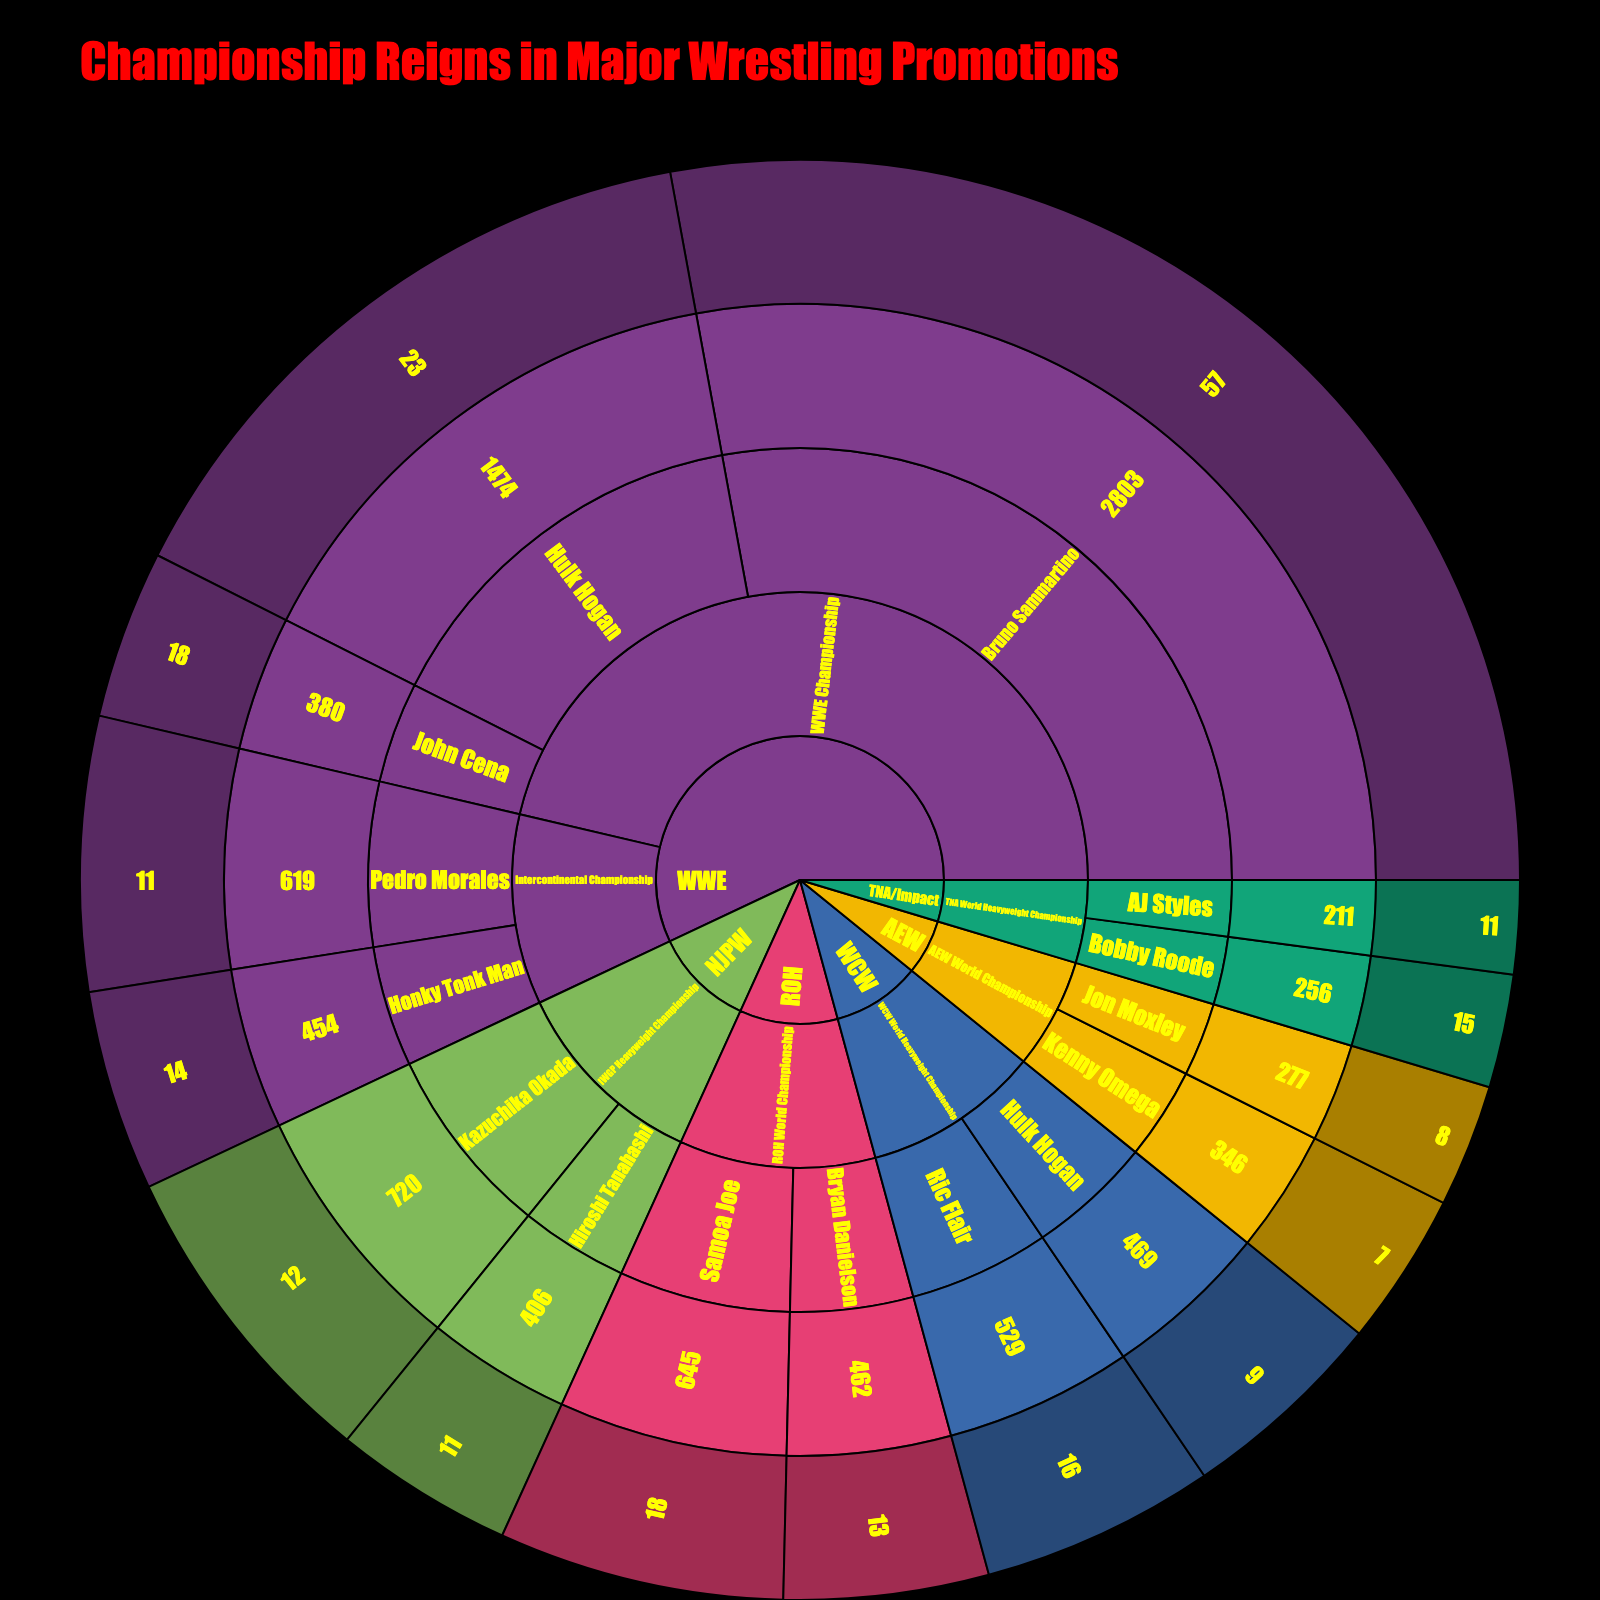what is the duration of Bruno Sammartino's WWE Championship reign? Look for Bruno Sammartino's section under WWE Championship in the Sunburst Plot. The reign duration is displayed in the hover data, showing 2803 days.
Answer: 2803 days who had the longest reign among AEW World Champions? Check the sections under AEW World Championship. Compare the durations of Kenny Omega (346 days) and Jon Moxley (277 days). Kenny Omega had the longest reign.
Answer: Kenny Omega how many title defenses did Hulk Hogan make during his longest WWE Championship reign? Under WWE Championship, locate Hulk Hogan's section. The hover data indicates 23 title defenses.
Answer: 23 defenses compare the number of defenses between Samoa Joe and Bryan Danielson’s ROH World Championship reigns. Who had more? Under ROH World Championship, compare the title defenses of Samoa Joe (18) and Bryan Danielson (13). Samoa Joe had more defenses.
Answer: Samoa Joe what's the average duration of all WWE Championship reigns shown? Add the durations of Bruno Sammartino (2803), Hulk Hogan (1474), and John Cena (380). The total is 4657 days. Divide by the number of reigns (3) to get the average: 4657 / 3 = 1552.33 days.
Answer: 1552.33 days which wrestler had the shortest reign duration for the TNA World Heavyweight Championship? Under TNA World Heavyweight Championship, compare the durations of Bobby Roode (256 days) and AJ Styles (211 days). AJ Styles had the shortest reign.
Answer: AJ Styles how many wrestlers have more than 10 defenses for the Intercontinental Championship in WWE? Look at WWE's Intercontinental Championship sections for Honky Tonk Man (14 defenses) and Pedro Morales (11 defenses). Both have more than 10 defenses.
Answer: 2 wrestlers what's the difference in reign duration between Kazuchika Okada and Hiroshi Tanahashi in NJPW? Check NJPW's IWGP Heavyweight Championship reigns. Kazuchika Okada had 720 days and Hiroshi Tanahashi had 406 days. The difference is 720 - 406 = 314 days.
Answer: 314 days which promotion has the most title reigns listed in the plot? Count the number of title reigns per promotion. WWE (5), AEW (2), NJPW (2), WCW (2), ROH (2), TNA/Impact (2). WWE has the most.
Answer: WWE 